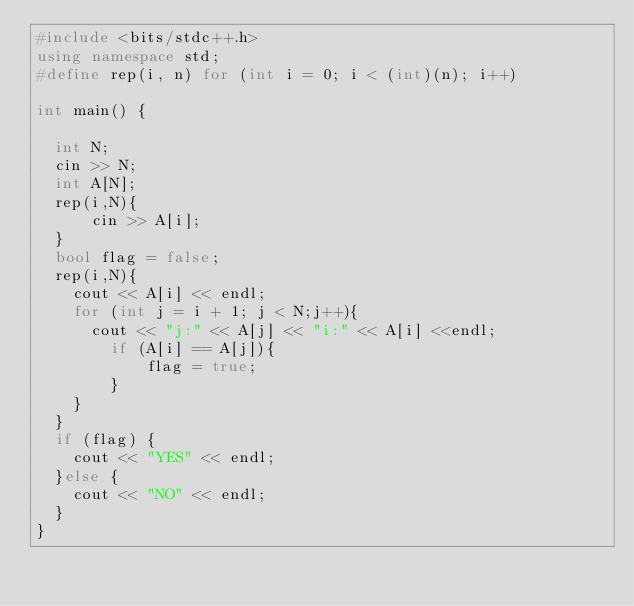<code> <loc_0><loc_0><loc_500><loc_500><_C++_>#include <bits/stdc++.h>
using namespace std;
#define rep(i, n) for (int i = 0; i < (int)(n); i++)

int main() {
    
  int N;
  cin >> N;
  int A[N];
  rep(i,N){
      cin >> A[i];
  }
  bool flag = false;
  rep(i,N){
    cout << A[i] << endl;
    for (int j = i + 1; j < N;j++){
      cout << "j:" << A[j] << "i:" << A[i] <<endl;
        if (A[i] == A[j]){
            flag = true;
        }
    }
  }
  if (flag) {
    cout << "YES" << endl;
  }else {
    cout << "NO" << endl;
  }
}</code> 